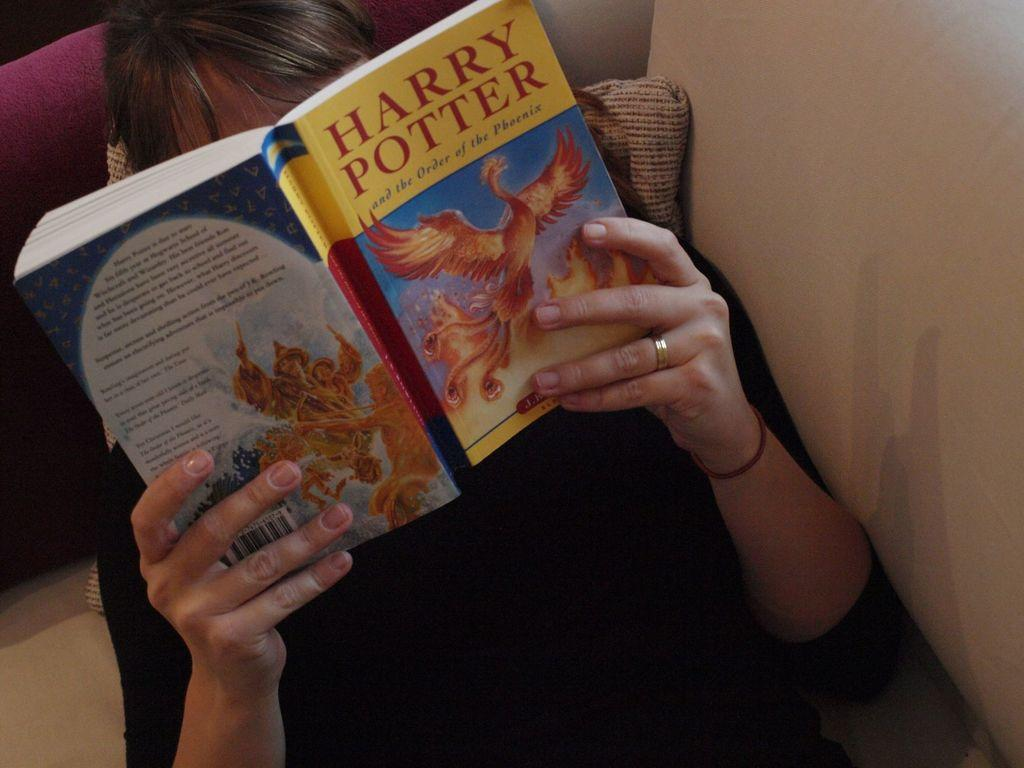<image>
Offer a succinct explanation of the picture presented. Someone is reading Harry Potter and the Order of the Phoenix. 